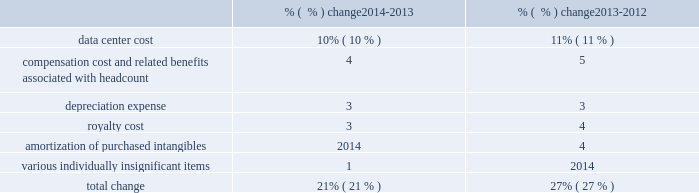Subscription cost of subscription revenue consists of third-party royalties and expenses related to operating our network infrastructure , including depreciation expenses and operating lease payments associated with computer equipment , data center costs , salaries and related expenses of network operations , implementation , account management and technical support personnel , amortization of intangible assets and allocated overhead .
We enter into contracts with third-parties for the use of their data center facilities and our data center costs largely consist of the amounts we pay to these third parties for rack space , power and similar items .
Cost of subscription revenue increased due to the following : % (  % ) change 2014-2013 % (  % ) change 2013-2012 .
Cost of subscription revenue increased during fiscal 2014 as compared to fiscal 2013 primarily due to data center costs , compensation cost and related benefits , deprecation expense , and royalty cost .
Data center costs increased as compared with the year-ago period primarily due to higher transaction volumes in our adobe marketing cloud and creative cloud services .
Compensation cost and related benefits increased as compared to the year-ago period primarily due to additional headcount in fiscal 2014 , including from our acquisition of neolane in the third quarter of fiscal 2013 .
Depreciation expense increased as compared to the year-ago period primarily due to higher capital expenditures in recent periods as we continue to invest in our network and data center infrastructure to support the growth of our business .
Royalty cost increased primarily due to increases in subscriptions and downloads of our saas offerings .
Cost of subscription revenue increased during fiscal 2013 as compared to fiscal 2012 primarily due to increased hosted server costs and amortization of purchased intangibles .
Hosted server costs increased primarily due to increases in data center costs related to higher transaction volumes in our adobe marketing cloud and creative cloud services , depreciation expense from higher capital expenditures in prior years and compensation and related benefits driven by additional headcount .
Amortization of purchased intangibles increased primarily due to increased amortization of intangible assets purchased associated with our acquisitions of behance and neolane in fiscal 2013 .
Services and support cost of services and support revenue is primarily comprised of employee-related costs and associated costs incurred to provide consulting services , training and product support .
Cost of services and support revenue increased during fiscal 2014 as compared to fiscal 2013 primarily due to increases in compensation and related benefits driven by additional headcount and third-party fees related to training and consulting services provided to our customers .
Cost of services and support revenue increased during fiscal 2013 as compared to fiscal 2012 primarily due to increases in third-party fees related to training and consulting services provided to our customers and compensation and related benefits driven by additional headcount , including headcount from our acquisition of neolane in fiscal 2013. .
From the years 2014-2013 to 2013-2012 , what was the change in percentage points of data center cost? 
Computations: (10 - 11)
Answer: -1.0. 